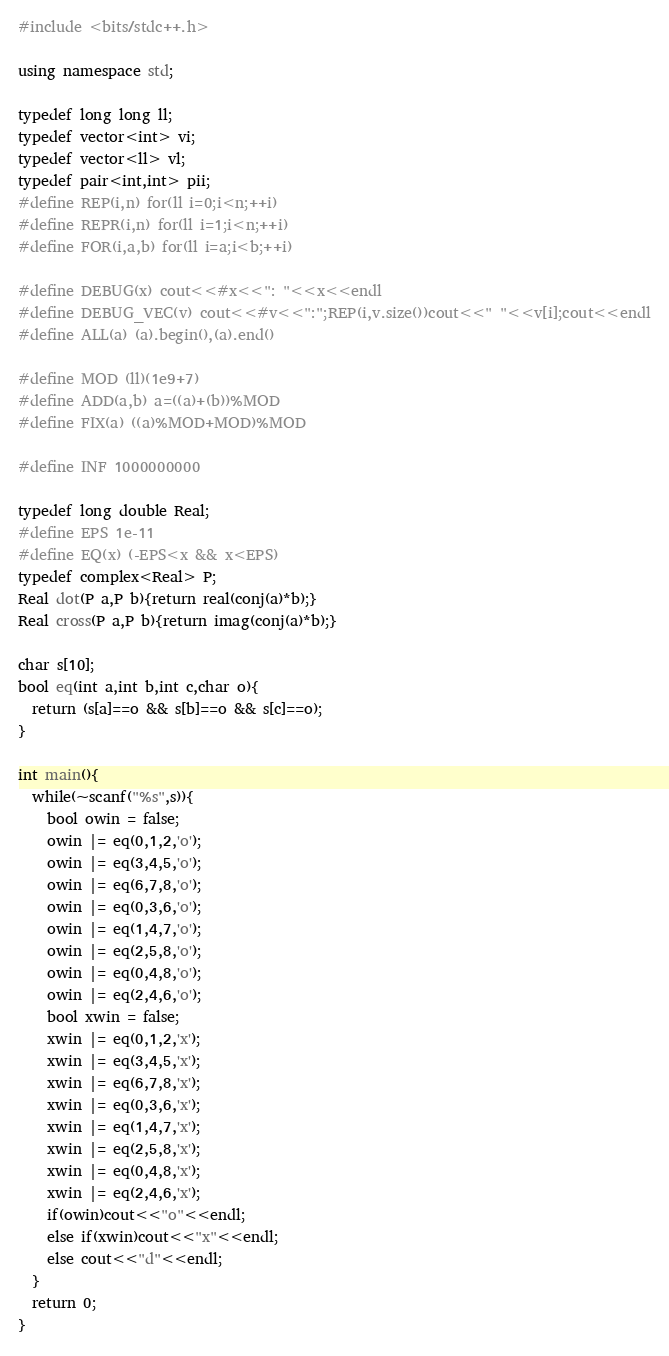Convert code to text. <code><loc_0><loc_0><loc_500><loc_500><_C++_>#include <bits/stdc++.h>
  
using namespace std;
  
typedef long long ll;
typedef vector<int> vi;
typedef vector<ll> vl;
typedef pair<int,int> pii;
#define REP(i,n) for(ll i=0;i<n;++i)
#define REPR(i,n) for(ll i=1;i<n;++i)
#define FOR(i,a,b) for(ll i=a;i<b;++i)
  
#define DEBUG(x) cout<<#x<<": "<<x<<endl
#define DEBUG_VEC(v) cout<<#v<<":";REP(i,v.size())cout<<" "<<v[i];cout<<endl
#define ALL(a) (a).begin(),(a).end()
  
#define MOD (ll)(1e9+7)
#define ADD(a,b) a=((a)+(b))%MOD
#define FIX(a) ((a)%MOD+MOD)%MOD

#define INF 1000000000

typedef long double Real;
#define EPS 1e-11
#define EQ(x) (-EPS<x && x<EPS)
typedef complex<Real> P;
Real dot(P a,P b){return real(conj(a)*b);}
Real cross(P a,P b){return imag(conj(a)*b);}

char s[10];
bool eq(int a,int b,int c,char o){
  return (s[a]==o && s[b]==o && s[c]==o);
}

int main(){
  while(~scanf("%s",s)){
    bool owin = false;
    owin |= eq(0,1,2,'o');
    owin |= eq(3,4,5,'o');
    owin |= eq(6,7,8,'o');
    owin |= eq(0,3,6,'o');
    owin |= eq(1,4,7,'o');
    owin |= eq(2,5,8,'o');
    owin |= eq(0,4,8,'o');
    owin |= eq(2,4,6,'o');
    bool xwin = false;
    xwin |= eq(0,1,2,'x');
    xwin |= eq(3,4,5,'x');
    xwin |= eq(6,7,8,'x');
    xwin |= eq(0,3,6,'x');
    xwin |= eq(1,4,7,'x');
    xwin |= eq(2,5,8,'x');
    xwin |= eq(0,4,8,'x');
    xwin |= eq(2,4,6,'x');
    if(owin)cout<<"o"<<endl;
    else if(xwin)cout<<"x"<<endl;
    else cout<<"d"<<endl;
  }
  return 0;
}</code> 